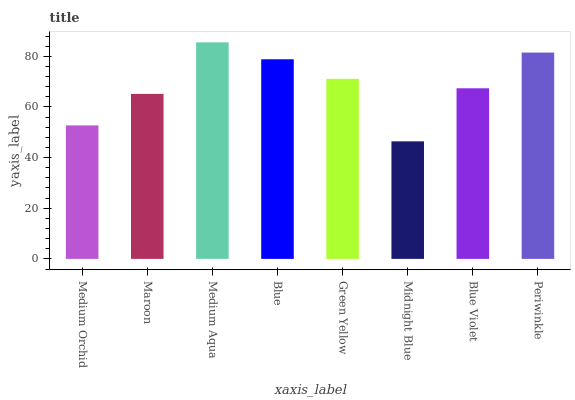Is Midnight Blue the minimum?
Answer yes or no. Yes. Is Medium Aqua the maximum?
Answer yes or no. Yes. Is Maroon the minimum?
Answer yes or no. No. Is Maroon the maximum?
Answer yes or no. No. Is Maroon greater than Medium Orchid?
Answer yes or no. Yes. Is Medium Orchid less than Maroon?
Answer yes or no. Yes. Is Medium Orchid greater than Maroon?
Answer yes or no. No. Is Maroon less than Medium Orchid?
Answer yes or no. No. Is Green Yellow the high median?
Answer yes or no. Yes. Is Blue Violet the low median?
Answer yes or no. Yes. Is Blue Violet the high median?
Answer yes or no. No. Is Medium Aqua the low median?
Answer yes or no. No. 